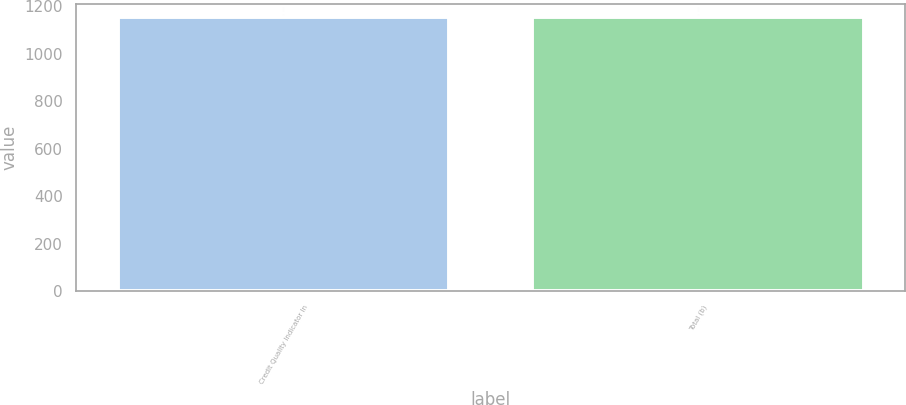Convert chart. <chart><loc_0><loc_0><loc_500><loc_500><bar_chart><fcel>Credit Quality Indicator In<fcel>Total (b)<nl><fcel>1153<fcel>1153.1<nl></chart> 